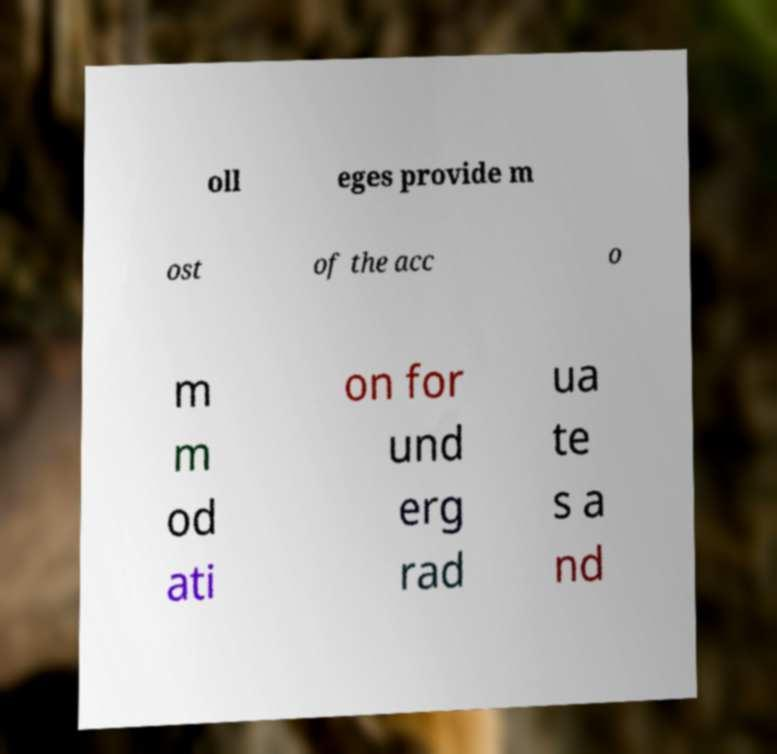Please identify and transcribe the text found in this image. oll eges provide m ost of the acc o m m od ati on for und erg rad ua te s a nd 